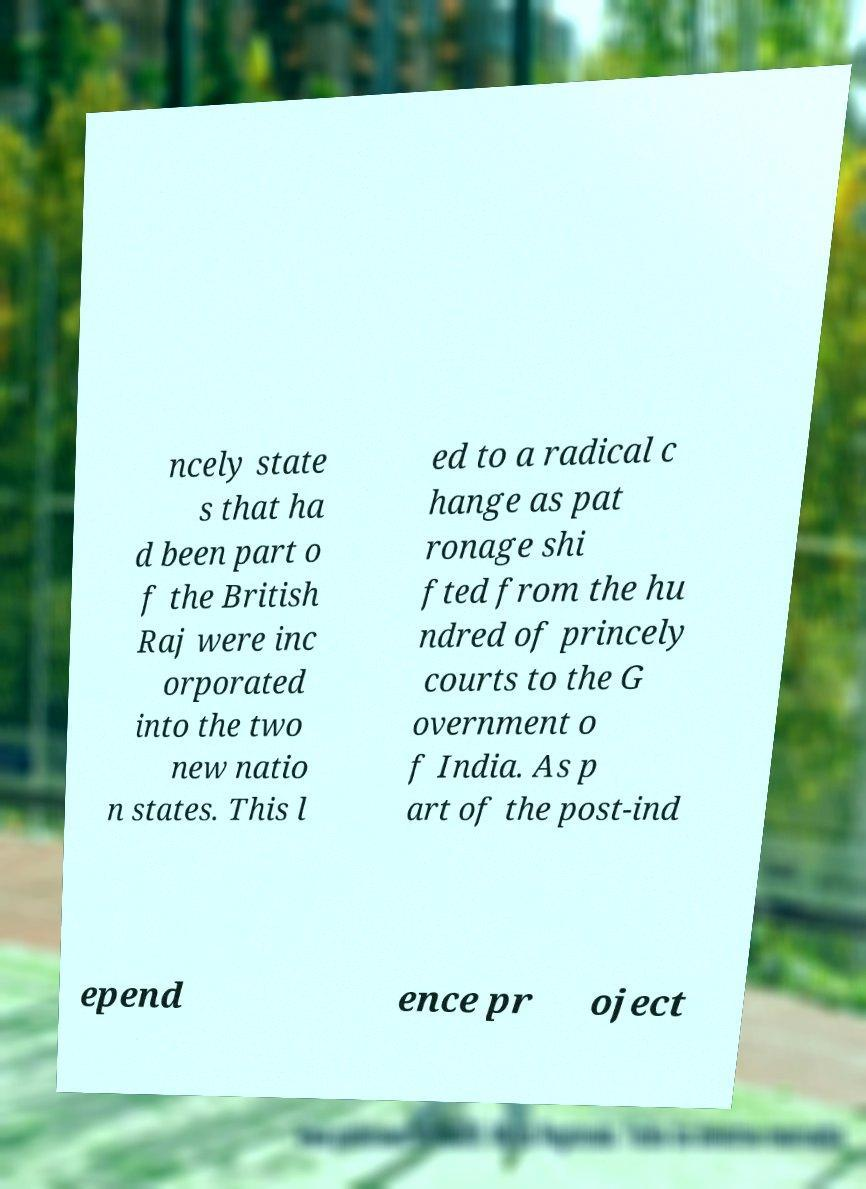There's text embedded in this image that I need extracted. Can you transcribe it verbatim? ncely state s that ha d been part o f the British Raj were inc orporated into the two new natio n states. This l ed to a radical c hange as pat ronage shi fted from the hu ndred of princely courts to the G overnment o f India. As p art of the post-ind epend ence pr oject 